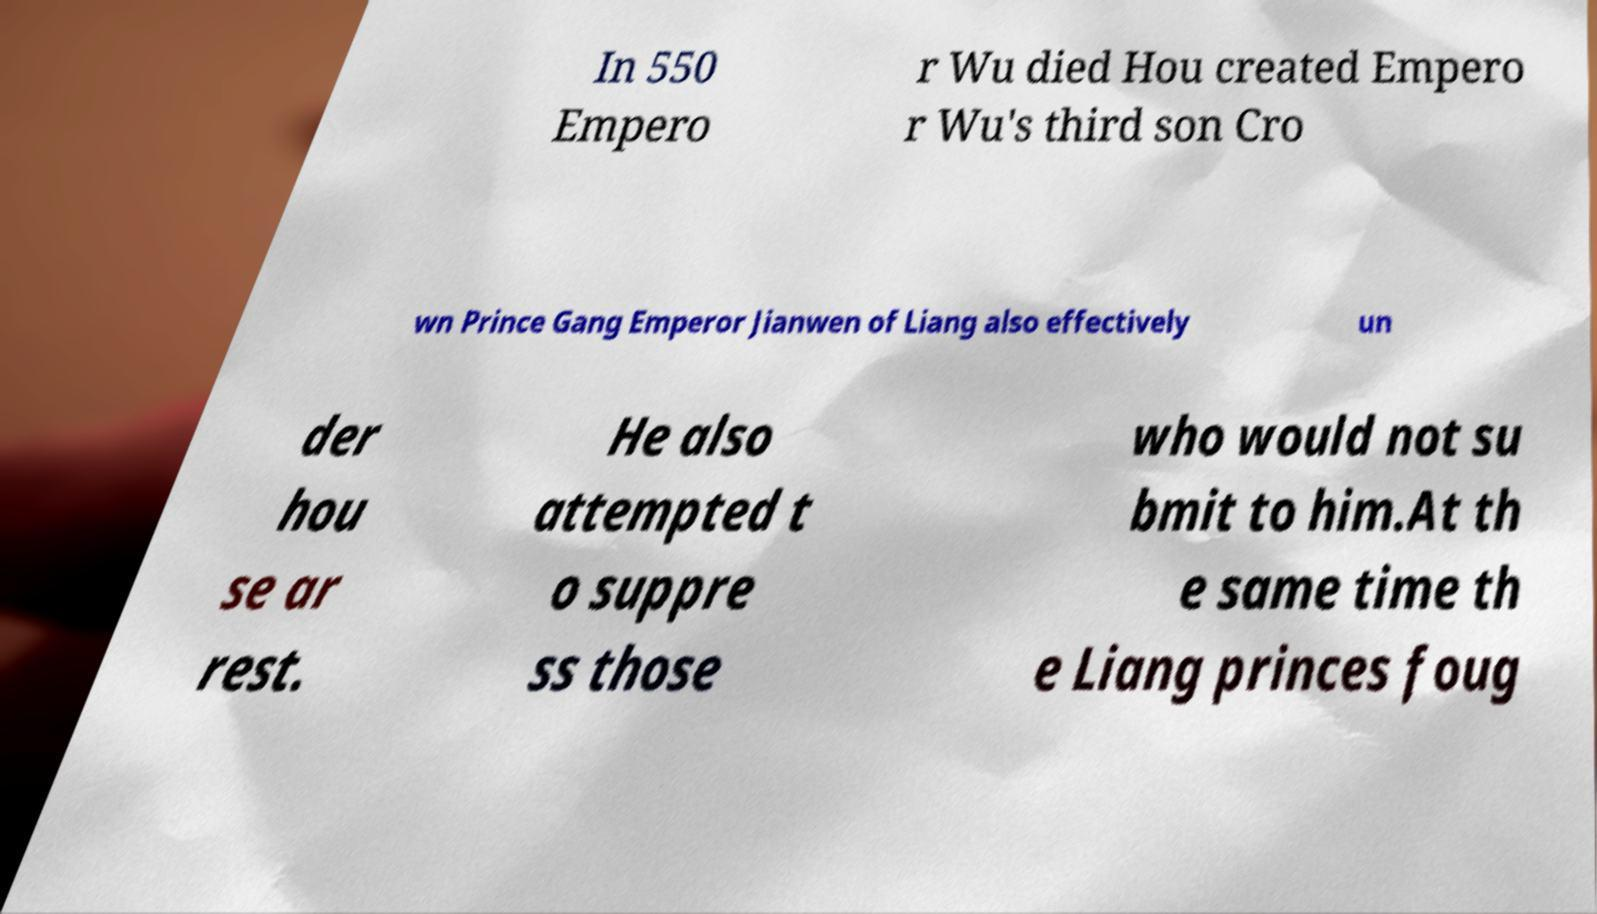There's text embedded in this image that I need extracted. Can you transcribe it verbatim? In 550 Empero r Wu died Hou created Empero r Wu's third son Cro wn Prince Gang Emperor Jianwen of Liang also effectively un der hou se ar rest. He also attempted t o suppre ss those who would not su bmit to him.At th e same time th e Liang princes foug 